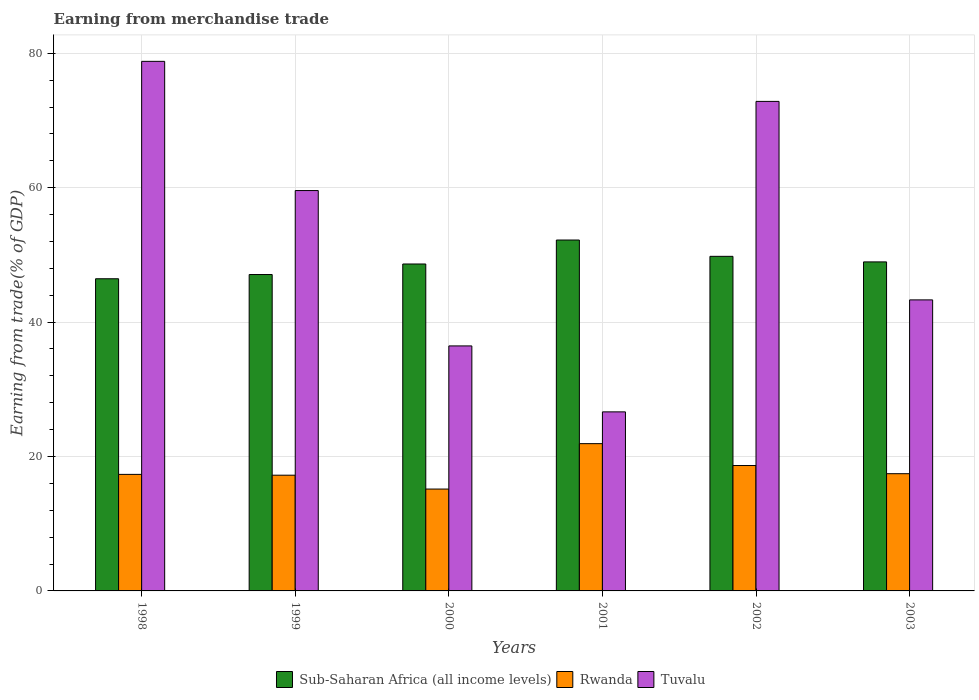How many different coloured bars are there?
Provide a short and direct response. 3. How many bars are there on the 1st tick from the right?
Make the answer very short. 3. In how many cases, is the number of bars for a given year not equal to the number of legend labels?
Ensure brevity in your answer.  0. What is the earnings from trade in Tuvalu in 2000?
Your answer should be very brief. 36.46. Across all years, what is the maximum earnings from trade in Sub-Saharan Africa (all income levels)?
Offer a terse response. 52.21. Across all years, what is the minimum earnings from trade in Tuvalu?
Ensure brevity in your answer.  26.64. What is the total earnings from trade in Rwanda in the graph?
Your answer should be compact. 107.74. What is the difference between the earnings from trade in Rwanda in 1998 and that in 1999?
Your response must be concise. 0.12. What is the difference between the earnings from trade in Sub-Saharan Africa (all income levels) in 2000 and the earnings from trade in Tuvalu in 2003?
Your answer should be very brief. 5.34. What is the average earnings from trade in Sub-Saharan Africa (all income levels) per year?
Ensure brevity in your answer.  48.86. In the year 1998, what is the difference between the earnings from trade in Sub-Saharan Africa (all income levels) and earnings from trade in Tuvalu?
Make the answer very short. -32.35. In how many years, is the earnings from trade in Tuvalu greater than 56 %?
Make the answer very short. 3. What is the ratio of the earnings from trade in Tuvalu in 1998 to that in 2002?
Give a very brief answer. 1.08. Is the earnings from trade in Rwanda in 1998 less than that in 2003?
Your answer should be very brief. Yes. What is the difference between the highest and the second highest earnings from trade in Sub-Saharan Africa (all income levels)?
Provide a short and direct response. 2.43. What is the difference between the highest and the lowest earnings from trade in Tuvalu?
Provide a succinct answer. 52.16. Is the sum of the earnings from trade in Tuvalu in 1998 and 1999 greater than the maximum earnings from trade in Sub-Saharan Africa (all income levels) across all years?
Your answer should be very brief. Yes. What does the 3rd bar from the left in 1998 represents?
Offer a terse response. Tuvalu. What does the 2nd bar from the right in 2001 represents?
Your response must be concise. Rwanda. Are the values on the major ticks of Y-axis written in scientific E-notation?
Give a very brief answer. No. Does the graph contain any zero values?
Your answer should be compact. No. How many legend labels are there?
Keep it short and to the point. 3. What is the title of the graph?
Keep it short and to the point. Earning from merchandise trade. Does "Guyana" appear as one of the legend labels in the graph?
Offer a very short reply. No. What is the label or title of the X-axis?
Your response must be concise. Years. What is the label or title of the Y-axis?
Keep it short and to the point. Earning from trade(% of GDP). What is the Earning from trade(% of GDP) of Sub-Saharan Africa (all income levels) in 1998?
Offer a very short reply. 46.45. What is the Earning from trade(% of GDP) in Rwanda in 1998?
Your answer should be compact. 17.34. What is the Earning from trade(% of GDP) in Tuvalu in 1998?
Your answer should be compact. 78.8. What is the Earning from trade(% of GDP) of Sub-Saharan Africa (all income levels) in 1999?
Give a very brief answer. 47.08. What is the Earning from trade(% of GDP) in Rwanda in 1999?
Offer a terse response. 17.22. What is the Earning from trade(% of GDP) in Tuvalu in 1999?
Offer a very short reply. 59.58. What is the Earning from trade(% of GDP) of Sub-Saharan Africa (all income levels) in 2000?
Your answer should be compact. 48.65. What is the Earning from trade(% of GDP) in Rwanda in 2000?
Provide a short and direct response. 15.16. What is the Earning from trade(% of GDP) in Tuvalu in 2000?
Give a very brief answer. 36.46. What is the Earning from trade(% of GDP) of Sub-Saharan Africa (all income levels) in 2001?
Your response must be concise. 52.21. What is the Earning from trade(% of GDP) in Rwanda in 2001?
Make the answer very short. 21.91. What is the Earning from trade(% of GDP) in Tuvalu in 2001?
Ensure brevity in your answer.  26.64. What is the Earning from trade(% of GDP) of Sub-Saharan Africa (all income levels) in 2002?
Give a very brief answer. 49.79. What is the Earning from trade(% of GDP) in Rwanda in 2002?
Offer a terse response. 18.66. What is the Earning from trade(% of GDP) in Tuvalu in 2002?
Keep it short and to the point. 72.84. What is the Earning from trade(% of GDP) of Sub-Saharan Africa (all income levels) in 2003?
Your response must be concise. 48.96. What is the Earning from trade(% of GDP) in Rwanda in 2003?
Your answer should be very brief. 17.44. What is the Earning from trade(% of GDP) of Tuvalu in 2003?
Provide a short and direct response. 43.31. Across all years, what is the maximum Earning from trade(% of GDP) of Sub-Saharan Africa (all income levels)?
Your answer should be very brief. 52.21. Across all years, what is the maximum Earning from trade(% of GDP) in Rwanda?
Provide a succinct answer. 21.91. Across all years, what is the maximum Earning from trade(% of GDP) in Tuvalu?
Keep it short and to the point. 78.8. Across all years, what is the minimum Earning from trade(% of GDP) in Sub-Saharan Africa (all income levels)?
Ensure brevity in your answer.  46.45. Across all years, what is the minimum Earning from trade(% of GDP) of Rwanda?
Keep it short and to the point. 15.16. Across all years, what is the minimum Earning from trade(% of GDP) of Tuvalu?
Provide a short and direct response. 26.64. What is the total Earning from trade(% of GDP) in Sub-Saharan Africa (all income levels) in the graph?
Provide a succinct answer. 293.14. What is the total Earning from trade(% of GDP) in Rwanda in the graph?
Your answer should be very brief. 107.74. What is the total Earning from trade(% of GDP) in Tuvalu in the graph?
Offer a very short reply. 317.63. What is the difference between the Earning from trade(% of GDP) of Sub-Saharan Africa (all income levels) in 1998 and that in 1999?
Provide a succinct answer. -0.63. What is the difference between the Earning from trade(% of GDP) in Rwanda in 1998 and that in 1999?
Make the answer very short. 0.12. What is the difference between the Earning from trade(% of GDP) of Tuvalu in 1998 and that in 1999?
Make the answer very short. 19.23. What is the difference between the Earning from trade(% of GDP) in Sub-Saharan Africa (all income levels) in 1998 and that in 2000?
Ensure brevity in your answer.  -2.2. What is the difference between the Earning from trade(% of GDP) of Rwanda in 1998 and that in 2000?
Your response must be concise. 2.18. What is the difference between the Earning from trade(% of GDP) of Tuvalu in 1998 and that in 2000?
Offer a terse response. 42.34. What is the difference between the Earning from trade(% of GDP) of Sub-Saharan Africa (all income levels) in 1998 and that in 2001?
Your response must be concise. -5.76. What is the difference between the Earning from trade(% of GDP) of Rwanda in 1998 and that in 2001?
Give a very brief answer. -4.57. What is the difference between the Earning from trade(% of GDP) of Tuvalu in 1998 and that in 2001?
Ensure brevity in your answer.  52.16. What is the difference between the Earning from trade(% of GDP) of Sub-Saharan Africa (all income levels) in 1998 and that in 2002?
Your answer should be very brief. -3.34. What is the difference between the Earning from trade(% of GDP) of Rwanda in 1998 and that in 2002?
Your answer should be very brief. -1.32. What is the difference between the Earning from trade(% of GDP) in Tuvalu in 1998 and that in 2002?
Your answer should be very brief. 5.96. What is the difference between the Earning from trade(% of GDP) of Sub-Saharan Africa (all income levels) in 1998 and that in 2003?
Provide a short and direct response. -2.51. What is the difference between the Earning from trade(% of GDP) in Rwanda in 1998 and that in 2003?
Give a very brief answer. -0.1. What is the difference between the Earning from trade(% of GDP) in Tuvalu in 1998 and that in 2003?
Give a very brief answer. 35.49. What is the difference between the Earning from trade(% of GDP) of Sub-Saharan Africa (all income levels) in 1999 and that in 2000?
Offer a very short reply. -1.57. What is the difference between the Earning from trade(% of GDP) in Rwanda in 1999 and that in 2000?
Your answer should be very brief. 2.06. What is the difference between the Earning from trade(% of GDP) in Tuvalu in 1999 and that in 2000?
Ensure brevity in your answer.  23.12. What is the difference between the Earning from trade(% of GDP) of Sub-Saharan Africa (all income levels) in 1999 and that in 2001?
Ensure brevity in your answer.  -5.13. What is the difference between the Earning from trade(% of GDP) of Rwanda in 1999 and that in 2001?
Your answer should be very brief. -4.69. What is the difference between the Earning from trade(% of GDP) of Tuvalu in 1999 and that in 2001?
Offer a terse response. 32.93. What is the difference between the Earning from trade(% of GDP) of Sub-Saharan Africa (all income levels) in 1999 and that in 2002?
Offer a terse response. -2.71. What is the difference between the Earning from trade(% of GDP) in Rwanda in 1999 and that in 2002?
Your response must be concise. -1.44. What is the difference between the Earning from trade(% of GDP) of Tuvalu in 1999 and that in 2002?
Ensure brevity in your answer.  -13.27. What is the difference between the Earning from trade(% of GDP) of Sub-Saharan Africa (all income levels) in 1999 and that in 2003?
Provide a short and direct response. -1.88. What is the difference between the Earning from trade(% of GDP) of Rwanda in 1999 and that in 2003?
Your answer should be very brief. -0.22. What is the difference between the Earning from trade(% of GDP) of Tuvalu in 1999 and that in 2003?
Give a very brief answer. 16.27. What is the difference between the Earning from trade(% of GDP) of Sub-Saharan Africa (all income levels) in 2000 and that in 2001?
Your answer should be very brief. -3.57. What is the difference between the Earning from trade(% of GDP) of Rwanda in 2000 and that in 2001?
Offer a very short reply. -6.76. What is the difference between the Earning from trade(% of GDP) in Tuvalu in 2000 and that in 2001?
Keep it short and to the point. 9.81. What is the difference between the Earning from trade(% of GDP) of Sub-Saharan Africa (all income levels) in 2000 and that in 2002?
Provide a succinct answer. -1.14. What is the difference between the Earning from trade(% of GDP) of Rwanda in 2000 and that in 2002?
Keep it short and to the point. -3.5. What is the difference between the Earning from trade(% of GDP) in Tuvalu in 2000 and that in 2002?
Offer a very short reply. -36.38. What is the difference between the Earning from trade(% of GDP) in Sub-Saharan Africa (all income levels) in 2000 and that in 2003?
Your answer should be compact. -0.31. What is the difference between the Earning from trade(% of GDP) in Rwanda in 2000 and that in 2003?
Provide a short and direct response. -2.28. What is the difference between the Earning from trade(% of GDP) of Tuvalu in 2000 and that in 2003?
Provide a short and direct response. -6.85. What is the difference between the Earning from trade(% of GDP) of Sub-Saharan Africa (all income levels) in 2001 and that in 2002?
Your answer should be compact. 2.43. What is the difference between the Earning from trade(% of GDP) in Rwanda in 2001 and that in 2002?
Offer a terse response. 3.26. What is the difference between the Earning from trade(% of GDP) of Tuvalu in 2001 and that in 2002?
Your answer should be compact. -46.2. What is the difference between the Earning from trade(% of GDP) in Sub-Saharan Africa (all income levels) in 2001 and that in 2003?
Provide a succinct answer. 3.25. What is the difference between the Earning from trade(% of GDP) of Rwanda in 2001 and that in 2003?
Offer a terse response. 4.47. What is the difference between the Earning from trade(% of GDP) of Tuvalu in 2001 and that in 2003?
Give a very brief answer. -16.66. What is the difference between the Earning from trade(% of GDP) in Sub-Saharan Africa (all income levels) in 2002 and that in 2003?
Provide a short and direct response. 0.83. What is the difference between the Earning from trade(% of GDP) of Rwanda in 2002 and that in 2003?
Keep it short and to the point. 1.22. What is the difference between the Earning from trade(% of GDP) in Tuvalu in 2002 and that in 2003?
Keep it short and to the point. 29.54. What is the difference between the Earning from trade(% of GDP) of Sub-Saharan Africa (all income levels) in 1998 and the Earning from trade(% of GDP) of Rwanda in 1999?
Keep it short and to the point. 29.23. What is the difference between the Earning from trade(% of GDP) in Sub-Saharan Africa (all income levels) in 1998 and the Earning from trade(% of GDP) in Tuvalu in 1999?
Offer a terse response. -13.12. What is the difference between the Earning from trade(% of GDP) in Rwanda in 1998 and the Earning from trade(% of GDP) in Tuvalu in 1999?
Give a very brief answer. -42.23. What is the difference between the Earning from trade(% of GDP) of Sub-Saharan Africa (all income levels) in 1998 and the Earning from trade(% of GDP) of Rwanda in 2000?
Ensure brevity in your answer.  31.29. What is the difference between the Earning from trade(% of GDP) in Sub-Saharan Africa (all income levels) in 1998 and the Earning from trade(% of GDP) in Tuvalu in 2000?
Keep it short and to the point. 9.99. What is the difference between the Earning from trade(% of GDP) of Rwanda in 1998 and the Earning from trade(% of GDP) of Tuvalu in 2000?
Your answer should be compact. -19.12. What is the difference between the Earning from trade(% of GDP) in Sub-Saharan Africa (all income levels) in 1998 and the Earning from trade(% of GDP) in Rwanda in 2001?
Ensure brevity in your answer.  24.54. What is the difference between the Earning from trade(% of GDP) of Sub-Saharan Africa (all income levels) in 1998 and the Earning from trade(% of GDP) of Tuvalu in 2001?
Provide a succinct answer. 19.81. What is the difference between the Earning from trade(% of GDP) in Rwanda in 1998 and the Earning from trade(% of GDP) in Tuvalu in 2001?
Give a very brief answer. -9.3. What is the difference between the Earning from trade(% of GDP) in Sub-Saharan Africa (all income levels) in 1998 and the Earning from trade(% of GDP) in Rwanda in 2002?
Provide a short and direct response. 27.79. What is the difference between the Earning from trade(% of GDP) of Sub-Saharan Africa (all income levels) in 1998 and the Earning from trade(% of GDP) of Tuvalu in 2002?
Offer a very short reply. -26.39. What is the difference between the Earning from trade(% of GDP) of Rwanda in 1998 and the Earning from trade(% of GDP) of Tuvalu in 2002?
Offer a very short reply. -55.5. What is the difference between the Earning from trade(% of GDP) of Sub-Saharan Africa (all income levels) in 1998 and the Earning from trade(% of GDP) of Rwanda in 2003?
Offer a terse response. 29.01. What is the difference between the Earning from trade(% of GDP) of Sub-Saharan Africa (all income levels) in 1998 and the Earning from trade(% of GDP) of Tuvalu in 2003?
Provide a succinct answer. 3.14. What is the difference between the Earning from trade(% of GDP) in Rwanda in 1998 and the Earning from trade(% of GDP) in Tuvalu in 2003?
Your answer should be compact. -25.96. What is the difference between the Earning from trade(% of GDP) of Sub-Saharan Africa (all income levels) in 1999 and the Earning from trade(% of GDP) of Rwanda in 2000?
Your answer should be very brief. 31.92. What is the difference between the Earning from trade(% of GDP) in Sub-Saharan Africa (all income levels) in 1999 and the Earning from trade(% of GDP) in Tuvalu in 2000?
Make the answer very short. 10.62. What is the difference between the Earning from trade(% of GDP) in Rwanda in 1999 and the Earning from trade(% of GDP) in Tuvalu in 2000?
Your answer should be compact. -19.24. What is the difference between the Earning from trade(% of GDP) in Sub-Saharan Africa (all income levels) in 1999 and the Earning from trade(% of GDP) in Rwanda in 2001?
Your answer should be very brief. 25.17. What is the difference between the Earning from trade(% of GDP) in Sub-Saharan Africa (all income levels) in 1999 and the Earning from trade(% of GDP) in Tuvalu in 2001?
Your response must be concise. 20.44. What is the difference between the Earning from trade(% of GDP) of Rwanda in 1999 and the Earning from trade(% of GDP) of Tuvalu in 2001?
Give a very brief answer. -9.42. What is the difference between the Earning from trade(% of GDP) of Sub-Saharan Africa (all income levels) in 1999 and the Earning from trade(% of GDP) of Rwanda in 2002?
Give a very brief answer. 28.42. What is the difference between the Earning from trade(% of GDP) of Sub-Saharan Africa (all income levels) in 1999 and the Earning from trade(% of GDP) of Tuvalu in 2002?
Your answer should be very brief. -25.76. What is the difference between the Earning from trade(% of GDP) in Rwanda in 1999 and the Earning from trade(% of GDP) in Tuvalu in 2002?
Keep it short and to the point. -55.62. What is the difference between the Earning from trade(% of GDP) of Sub-Saharan Africa (all income levels) in 1999 and the Earning from trade(% of GDP) of Rwanda in 2003?
Your response must be concise. 29.64. What is the difference between the Earning from trade(% of GDP) in Sub-Saharan Africa (all income levels) in 1999 and the Earning from trade(% of GDP) in Tuvalu in 2003?
Offer a very short reply. 3.77. What is the difference between the Earning from trade(% of GDP) of Rwanda in 1999 and the Earning from trade(% of GDP) of Tuvalu in 2003?
Your answer should be very brief. -26.09. What is the difference between the Earning from trade(% of GDP) of Sub-Saharan Africa (all income levels) in 2000 and the Earning from trade(% of GDP) of Rwanda in 2001?
Give a very brief answer. 26.73. What is the difference between the Earning from trade(% of GDP) of Sub-Saharan Africa (all income levels) in 2000 and the Earning from trade(% of GDP) of Tuvalu in 2001?
Provide a succinct answer. 22. What is the difference between the Earning from trade(% of GDP) of Rwanda in 2000 and the Earning from trade(% of GDP) of Tuvalu in 2001?
Your answer should be very brief. -11.48. What is the difference between the Earning from trade(% of GDP) of Sub-Saharan Africa (all income levels) in 2000 and the Earning from trade(% of GDP) of Rwanda in 2002?
Your answer should be compact. 29.99. What is the difference between the Earning from trade(% of GDP) of Sub-Saharan Africa (all income levels) in 2000 and the Earning from trade(% of GDP) of Tuvalu in 2002?
Your answer should be compact. -24.19. What is the difference between the Earning from trade(% of GDP) of Rwanda in 2000 and the Earning from trade(% of GDP) of Tuvalu in 2002?
Offer a terse response. -57.68. What is the difference between the Earning from trade(% of GDP) of Sub-Saharan Africa (all income levels) in 2000 and the Earning from trade(% of GDP) of Rwanda in 2003?
Your response must be concise. 31.21. What is the difference between the Earning from trade(% of GDP) of Sub-Saharan Africa (all income levels) in 2000 and the Earning from trade(% of GDP) of Tuvalu in 2003?
Your answer should be very brief. 5.34. What is the difference between the Earning from trade(% of GDP) of Rwanda in 2000 and the Earning from trade(% of GDP) of Tuvalu in 2003?
Provide a succinct answer. -28.15. What is the difference between the Earning from trade(% of GDP) of Sub-Saharan Africa (all income levels) in 2001 and the Earning from trade(% of GDP) of Rwanda in 2002?
Your answer should be very brief. 33.55. What is the difference between the Earning from trade(% of GDP) of Sub-Saharan Africa (all income levels) in 2001 and the Earning from trade(% of GDP) of Tuvalu in 2002?
Give a very brief answer. -20.63. What is the difference between the Earning from trade(% of GDP) of Rwanda in 2001 and the Earning from trade(% of GDP) of Tuvalu in 2002?
Provide a short and direct response. -50.93. What is the difference between the Earning from trade(% of GDP) of Sub-Saharan Africa (all income levels) in 2001 and the Earning from trade(% of GDP) of Rwanda in 2003?
Your answer should be compact. 34.77. What is the difference between the Earning from trade(% of GDP) in Sub-Saharan Africa (all income levels) in 2001 and the Earning from trade(% of GDP) in Tuvalu in 2003?
Keep it short and to the point. 8.91. What is the difference between the Earning from trade(% of GDP) in Rwanda in 2001 and the Earning from trade(% of GDP) in Tuvalu in 2003?
Offer a very short reply. -21.39. What is the difference between the Earning from trade(% of GDP) of Sub-Saharan Africa (all income levels) in 2002 and the Earning from trade(% of GDP) of Rwanda in 2003?
Offer a very short reply. 32.34. What is the difference between the Earning from trade(% of GDP) of Sub-Saharan Africa (all income levels) in 2002 and the Earning from trade(% of GDP) of Tuvalu in 2003?
Provide a succinct answer. 6.48. What is the difference between the Earning from trade(% of GDP) in Rwanda in 2002 and the Earning from trade(% of GDP) in Tuvalu in 2003?
Give a very brief answer. -24.65. What is the average Earning from trade(% of GDP) of Sub-Saharan Africa (all income levels) per year?
Ensure brevity in your answer.  48.86. What is the average Earning from trade(% of GDP) in Rwanda per year?
Ensure brevity in your answer.  17.96. What is the average Earning from trade(% of GDP) in Tuvalu per year?
Provide a short and direct response. 52.94. In the year 1998, what is the difference between the Earning from trade(% of GDP) in Sub-Saharan Africa (all income levels) and Earning from trade(% of GDP) in Rwanda?
Keep it short and to the point. 29.11. In the year 1998, what is the difference between the Earning from trade(% of GDP) of Sub-Saharan Africa (all income levels) and Earning from trade(% of GDP) of Tuvalu?
Offer a very short reply. -32.35. In the year 1998, what is the difference between the Earning from trade(% of GDP) of Rwanda and Earning from trade(% of GDP) of Tuvalu?
Give a very brief answer. -61.46. In the year 1999, what is the difference between the Earning from trade(% of GDP) of Sub-Saharan Africa (all income levels) and Earning from trade(% of GDP) of Rwanda?
Ensure brevity in your answer.  29.86. In the year 1999, what is the difference between the Earning from trade(% of GDP) of Sub-Saharan Africa (all income levels) and Earning from trade(% of GDP) of Tuvalu?
Your answer should be compact. -12.49. In the year 1999, what is the difference between the Earning from trade(% of GDP) in Rwanda and Earning from trade(% of GDP) in Tuvalu?
Your answer should be very brief. -42.36. In the year 2000, what is the difference between the Earning from trade(% of GDP) in Sub-Saharan Africa (all income levels) and Earning from trade(% of GDP) in Rwanda?
Make the answer very short. 33.49. In the year 2000, what is the difference between the Earning from trade(% of GDP) in Sub-Saharan Africa (all income levels) and Earning from trade(% of GDP) in Tuvalu?
Provide a short and direct response. 12.19. In the year 2000, what is the difference between the Earning from trade(% of GDP) in Rwanda and Earning from trade(% of GDP) in Tuvalu?
Offer a very short reply. -21.3. In the year 2001, what is the difference between the Earning from trade(% of GDP) of Sub-Saharan Africa (all income levels) and Earning from trade(% of GDP) of Rwanda?
Ensure brevity in your answer.  30.3. In the year 2001, what is the difference between the Earning from trade(% of GDP) in Sub-Saharan Africa (all income levels) and Earning from trade(% of GDP) in Tuvalu?
Provide a succinct answer. 25.57. In the year 2001, what is the difference between the Earning from trade(% of GDP) in Rwanda and Earning from trade(% of GDP) in Tuvalu?
Your response must be concise. -4.73. In the year 2002, what is the difference between the Earning from trade(% of GDP) of Sub-Saharan Africa (all income levels) and Earning from trade(% of GDP) of Rwanda?
Provide a succinct answer. 31.13. In the year 2002, what is the difference between the Earning from trade(% of GDP) in Sub-Saharan Africa (all income levels) and Earning from trade(% of GDP) in Tuvalu?
Provide a short and direct response. -23.05. In the year 2002, what is the difference between the Earning from trade(% of GDP) of Rwanda and Earning from trade(% of GDP) of Tuvalu?
Your response must be concise. -54.18. In the year 2003, what is the difference between the Earning from trade(% of GDP) in Sub-Saharan Africa (all income levels) and Earning from trade(% of GDP) in Rwanda?
Offer a terse response. 31.52. In the year 2003, what is the difference between the Earning from trade(% of GDP) of Sub-Saharan Africa (all income levels) and Earning from trade(% of GDP) of Tuvalu?
Provide a short and direct response. 5.65. In the year 2003, what is the difference between the Earning from trade(% of GDP) of Rwanda and Earning from trade(% of GDP) of Tuvalu?
Your response must be concise. -25.86. What is the ratio of the Earning from trade(% of GDP) in Sub-Saharan Africa (all income levels) in 1998 to that in 1999?
Your response must be concise. 0.99. What is the ratio of the Earning from trade(% of GDP) of Rwanda in 1998 to that in 1999?
Give a very brief answer. 1.01. What is the ratio of the Earning from trade(% of GDP) of Tuvalu in 1998 to that in 1999?
Make the answer very short. 1.32. What is the ratio of the Earning from trade(% of GDP) in Sub-Saharan Africa (all income levels) in 1998 to that in 2000?
Your answer should be very brief. 0.95. What is the ratio of the Earning from trade(% of GDP) of Rwanda in 1998 to that in 2000?
Offer a very short reply. 1.14. What is the ratio of the Earning from trade(% of GDP) in Tuvalu in 1998 to that in 2000?
Your answer should be compact. 2.16. What is the ratio of the Earning from trade(% of GDP) in Sub-Saharan Africa (all income levels) in 1998 to that in 2001?
Offer a terse response. 0.89. What is the ratio of the Earning from trade(% of GDP) of Rwanda in 1998 to that in 2001?
Make the answer very short. 0.79. What is the ratio of the Earning from trade(% of GDP) of Tuvalu in 1998 to that in 2001?
Offer a very short reply. 2.96. What is the ratio of the Earning from trade(% of GDP) of Sub-Saharan Africa (all income levels) in 1998 to that in 2002?
Offer a terse response. 0.93. What is the ratio of the Earning from trade(% of GDP) in Rwanda in 1998 to that in 2002?
Keep it short and to the point. 0.93. What is the ratio of the Earning from trade(% of GDP) in Tuvalu in 1998 to that in 2002?
Offer a terse response. 1.08. What is the ratio of the Earning from trade(% of GDP) in Sub-Saharan Africa (all income levels) in 1998 to that in 2003?
Your answer should be compact. 0.95. What is the ratio of the Earning from trade(% of GDP) of Tuvalu in 1998 to that in 2003?
Provide a short and direct response. 1.82. What is the ratio of the Earning from trade(% of GDP) of Sub-Saharan Africa (all income levels) in 1999 to that in 2000?
Your answer should be very brief. 0.97. What is the ratio of the Earning from trade(% of GDP) in Rwanda in 1999 to that in 2000?
Your answer should be compact. 1.14. What is the ratio of the Earning from trade(% of GDP) of Tuvalu in 1999 to that in 2000?
Your answer should be very brief. 1.63. What is the ratio of the Earning from trade(% of GDP) in Sub-Saharan Africa (all income levels) in 1999 to that in 2001?
Ensure brevity in your answer.  0.9. What is the ratio of the Earning from trade(% of GDP) in Rwanda in 1999 to that in 2001?
Make the answer very short. 0.79. What is the ratio of the Earning from trade(% of GDP) in Tuvalu in 1999 to that in 2001?
Give a very brief answer. 2.24. What is the ratio of the Earning from trade(% of GDP) of Sub-Saharan Africa (all income levels) in 1999 to that in 2002?
Give a very brief answer. 0.95. What is the ratio of the Earning from trade(% of GDP) in Rwanda in 1999 to that in 2002?
Provide a short and direct response. 0.92. What is the ratio of the Earning from trade(% of GDP) of Tuvalu in 1999 to that in 2002?
Offer a very short reply. 0.82. What is the ratio of the Earning from trade(% of GDP) in Sub-Saharan Africa (all income levels) in 1999 to that in 2003?
Make the answer very short. 0.96. What is the ratio of the Earning from trade(% of GDP) in Rwanda in 1999 to that in 2003?
Keep it short and to the point. 0.99. What is the ratio of the Earning from trade(% of GDP) in Tuvalu in 1999 to that in 2003?
Your response must be concise. 1.38. What is the ratio of the Earning from trade(% of GDP) of Sub-Saharan Africa (all income levels) in 2000 to that in 2001?
Your answer should be very brief. 0.93. What is the ratio of the Earning from trade(% of GDP) of Rwanda in 2000 to that in 2001?
Ensure brevity in your answer.  0.69. What is the ratio of the Earning from trade(% of GDP) in Tuvalu in 2000 to that in 2001?
Your answer should be compact. 1.37. What is the ratio of the Earning from trade(% of GDP) of Sub-Saharan Africa (all income levels) in 2000 to that in 2002?
Keep it short and to the point. 0.98. What is the ratio of the Earning from trade(% of GDP) in Rwanda in 2000 to that in 2002?
Your response must be concise. 0.81. What is the ratio of the Earning from trade(% of GDP) of Tuvalu in 2000 to that in 2002?
Provide a succinct answer. 0.5. What is the ratio of the Earning from trade(% of GDP) of Sub-Saharan Africa (all income levels) in 2000 to that in 2003?
Give a very brief answer. 0.99. What is the ratio of the Earning from trade(% of GDP) of Rwanda in 2000 to that in 2003?
Your answer should be compact. 0.87. What is the ratio of the Earning from trade(% of GDP) in Tuvalu in 2000 to that in 2003?
Your answer should be very brief. 0.84. What is the ratio of the Earning from trade(% of GDP) in Sub-Saharan Africa (all income levels) in 2001 to that in 2002?
Keep it short and to the point. 1.05. What is the ratio of the Earning from trade(% of GDP) in Rwanda in 2001 to that in 2002?
Offer a very short reply. 1.17. What is the ratio of the Earning from trade(% of GDP) in Tuvalu in 2001 to that in 2002?
Offer a very short reply. 0.37. What is the ratio of the Earning from trade(% of GDP) in Sub-Saharan Africa (all income levels) in 2001 to that in 2003?
Offer a very short reply. 1.07. What is the ratio of the Earning from trade(% of GDP) in Rwanda in 2001 to that in 2003?
Make the answer very short. 1.26. What is the ratio of the Earning from trade(% of GDP) in Tuvalu in 2001 to that in 2003?
Offer a terse response. 0.62. What is the ratio of the Earning from trade(% of GDP) of Sub-Saharan Africa (all income levels) in 2002 to that in 2003?
Offer a very short reply. 1.02. What is the ratio of the Earning from trade(% of GDP) in Rwanda in 2002 to that in 2003?
Your response must be concise. 1.07. What is the ratio of the Earning from trade(% of GDP) in Tuvalu in 2002 to that in 2003?
Offer a very short reply. 1.68. What is the difference between the highest and the second highest Earning from trade(% of GDP) in Sub-Saharan Africa (all income levels)?
Your answer should be very brief. 2.43. What is the difference between the highest and the second highest Earning from trade(% of GDP) in Rwanda?
Offer a terse response. 3.26. What is the difference between the highest and the second highest Earning from trade(% of GDP) in Tuvalu?
Offer a very short reply. 5.96. What is the difference between the highest and the lowest Earning from trade(% of GDP) in Sub-Saharan Africa (all income levels)?
Provide a short and direct response. 5.76. What is the difference between the highest and the lowest Earning from trade(% of GDP) of Rwanda?
Your answer should be compact. 6.76. What is the difference between the highest and the lowest Earning from trade(% of GDP) in Tuvalu?
Ensure brevity in your answer.  52.16. 